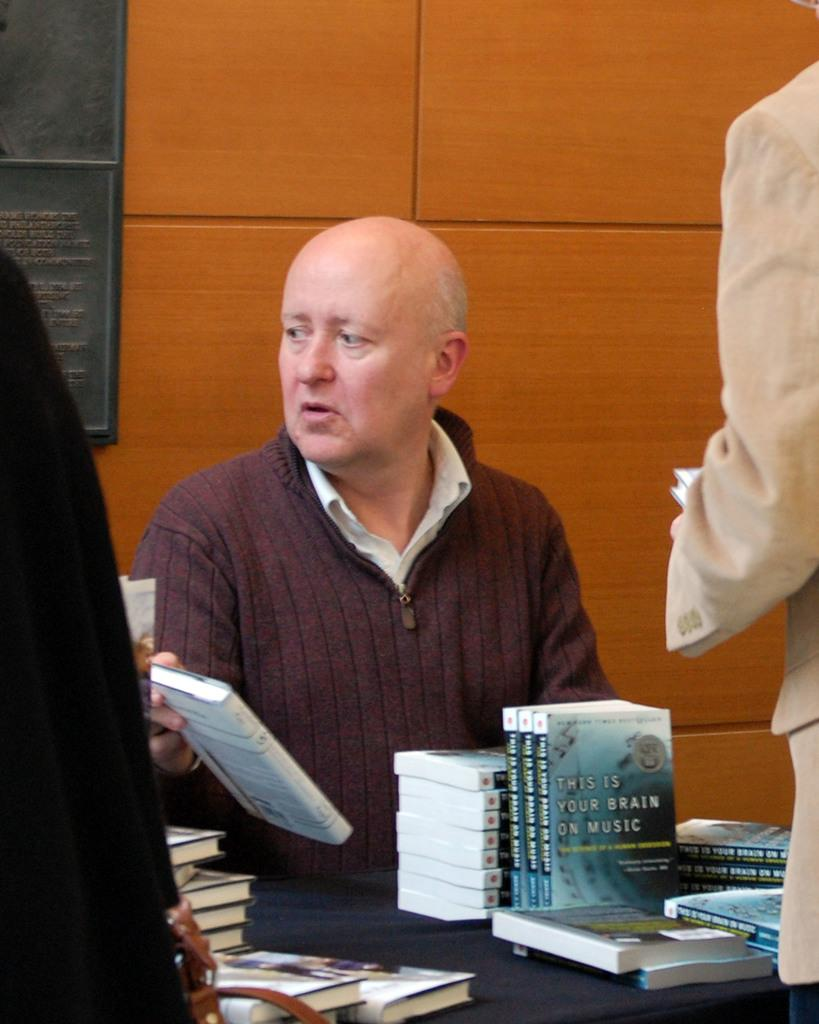<image>
Give a short and clear explanation of the subsequent image. A man sits at a table with many copies of a book called "This is your Brain on Music." 